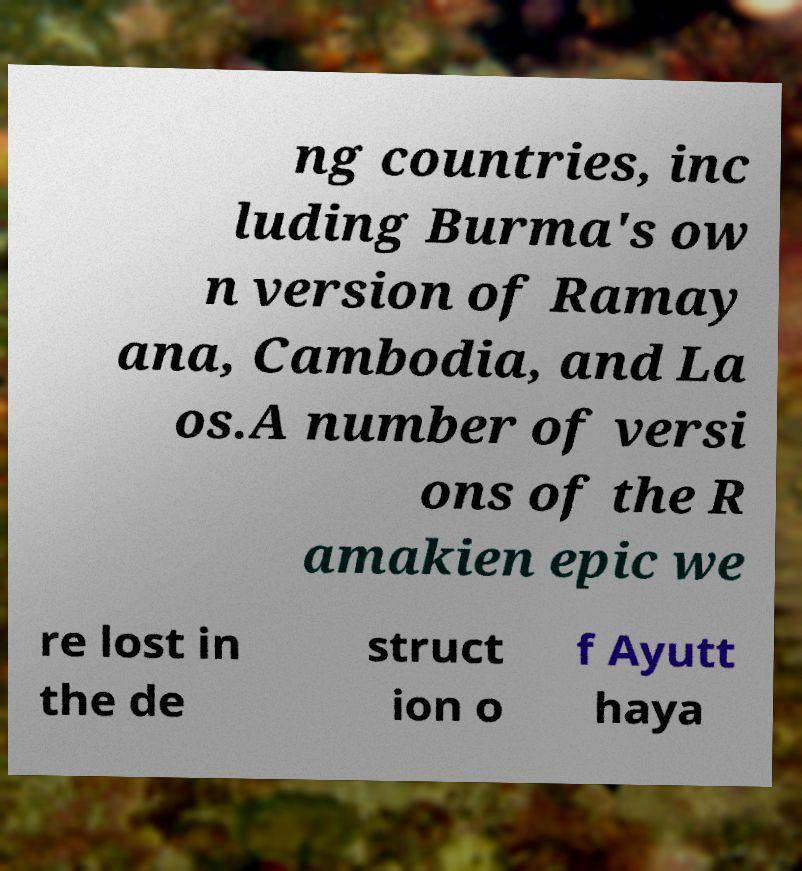There's text embedded in this image that I need extracted. Can you transcribe it verbatim? ng countries, inc luding Burma's ow n version of Ramay ana, Cambodia, and La os.A number of versi ons of the R amakien epic we re lost in the de struct ion o f Ayutt haya 